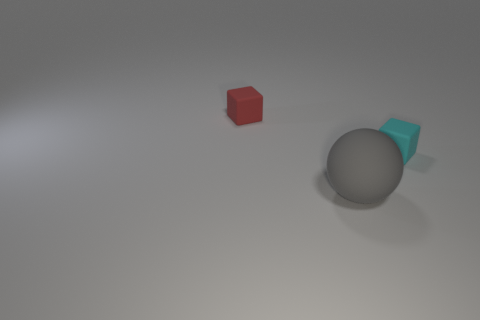What can you infer about the lighting and the environment where these objects are placed? The image shows the objects under an even, diffused light suggesting an indoor setting with soft lighting, likely from an overhead source. There are no harsh shadows or bright highlights, which indicates the absence of direct sunlight or powerful artificial spotlights. The environment appears to be a neutral grey surface with a subtle gradient, possibly a table or a platform in a studio setup designed to focus attention on the objects themselves without any distractions. 